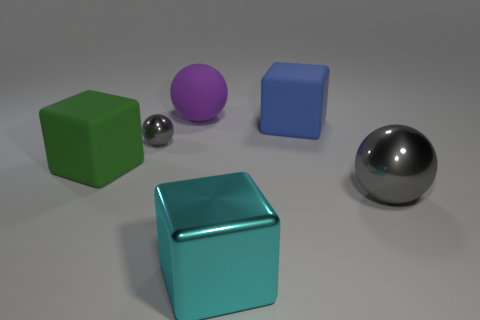What number of things are matte blocks that are left of the cyan metal thing or large cubes that are on the left side of the big purple ball?
Your answer should be compact. 1. Is the blue rubber block the same size as the cyan metallic object?
Make the answer very short. Yes. Are there more large blue blocks than objects?
Your answer should be compact. No. What number of other objects are the same color as the tiny object?
Your answer should be very brief. 1. How many objects are either big blue matte cubes or large cubes?
Your answer should be compact. 3. Does the gray metal thing that is to the left of the big gray metallic ball have the same shape as the large purple rubber object?
Your response must be concise. Yes. What color is the big sphere left of the block that is in front of the green thing?
Your response must be concise. Purple. Is the number of blue blocks less than the number of big gray matte cylinders?
Make the answer very short. No. Is there a blue cube that has the same material as the large purple sphere?
Offer a terse response. Yes. There is a big purple rubber thing; is it the same shape as the metal object that is in front of the big gray thing?
Your answer should be compact. No. 